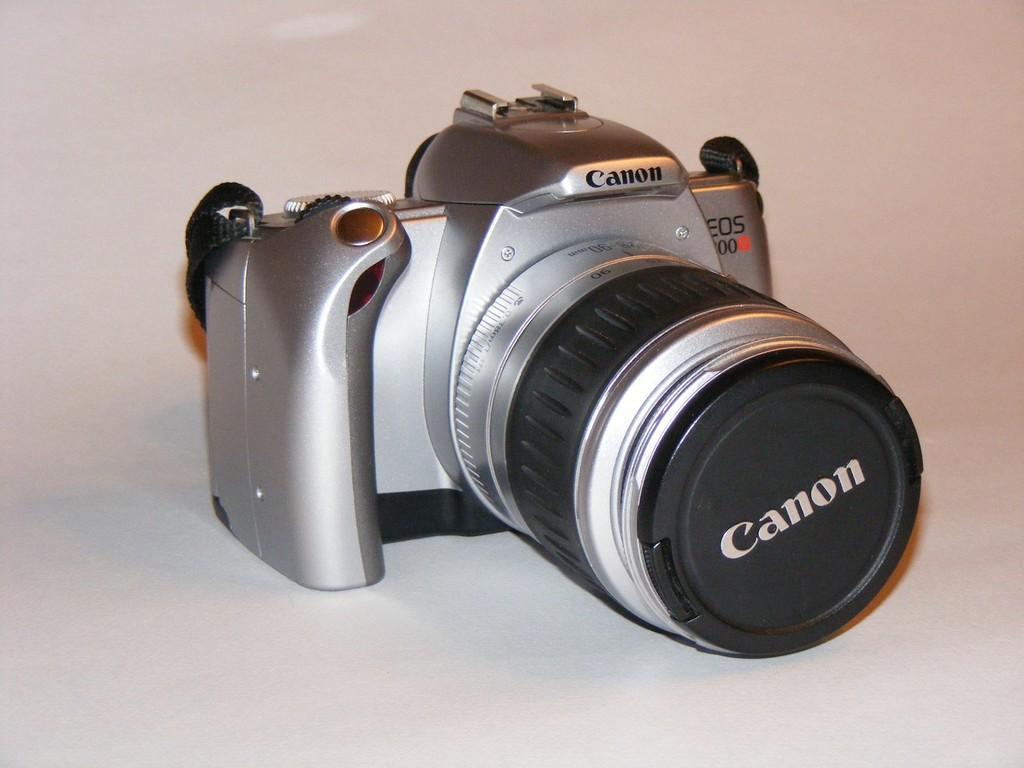Could you give a brief overview of what you see in this image? In this image, we can see a canon camera kept on the white surface. 